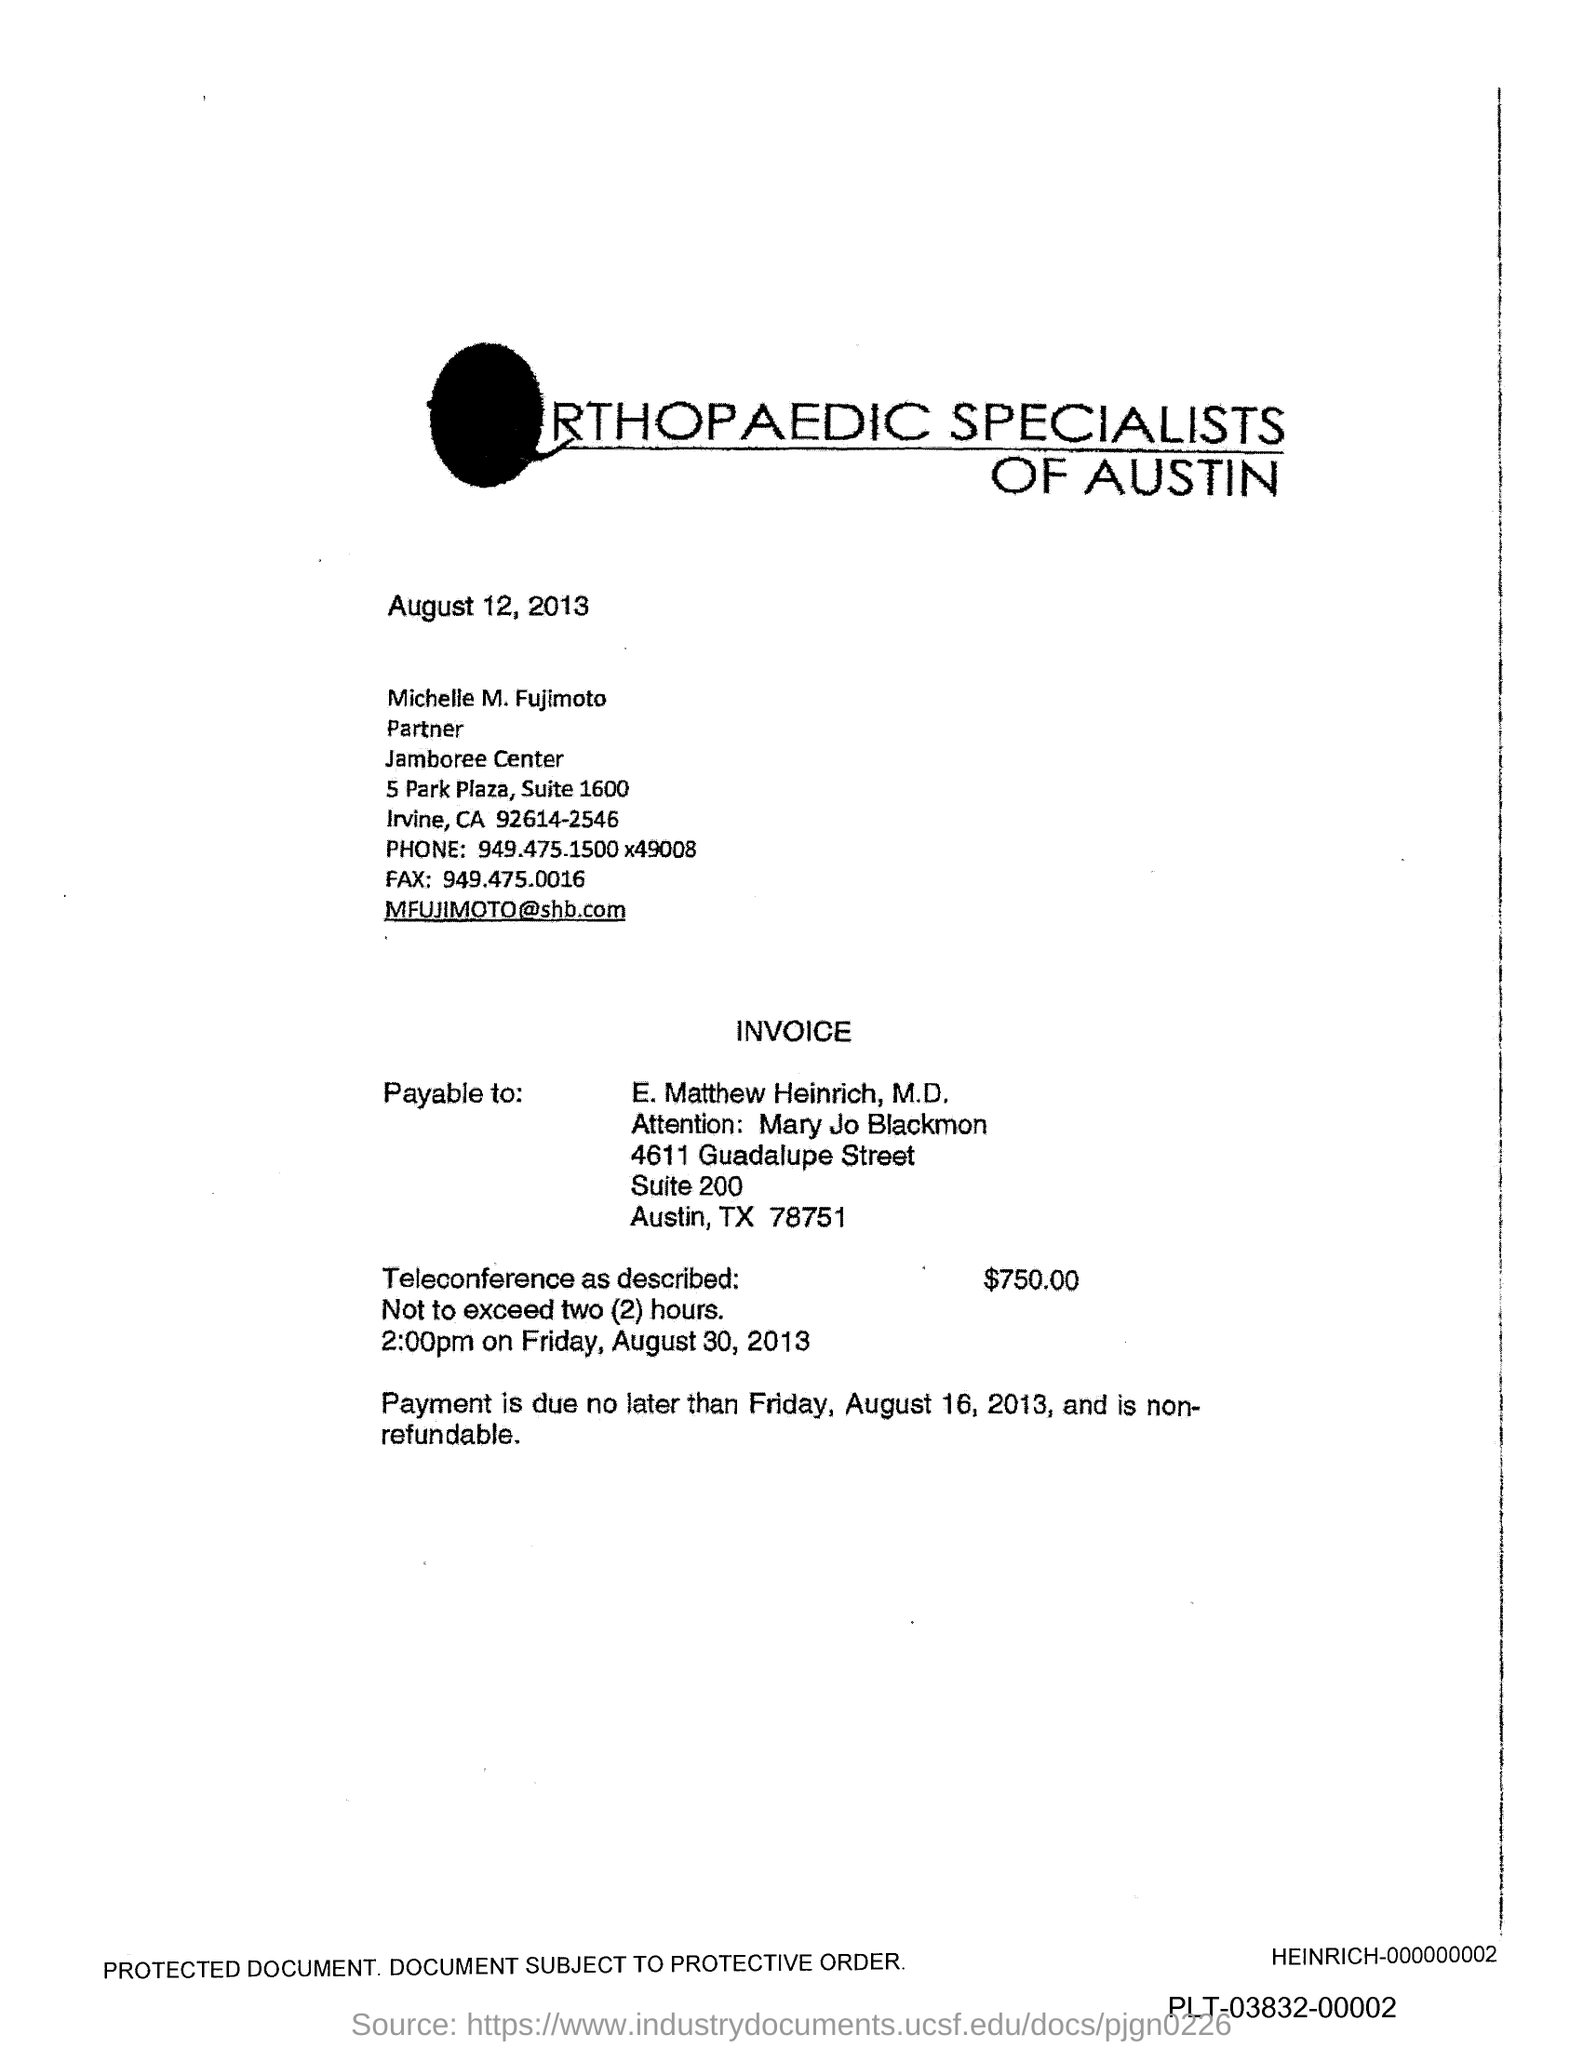What is the Fax number?
Your response must be concise. 949.475.0016. What is the phone number mentioned in the document?
Make the answer very short. 949.475.1500 x49008. 